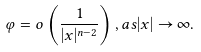Convert formula to latex. <formula><loc_0><loc_0><loc_500><loc_500>\varphi = o \left ( \frac { 1 } { | x | ^ { n - 2 } } \right ) , a s | x | \to \infty .</formula> 